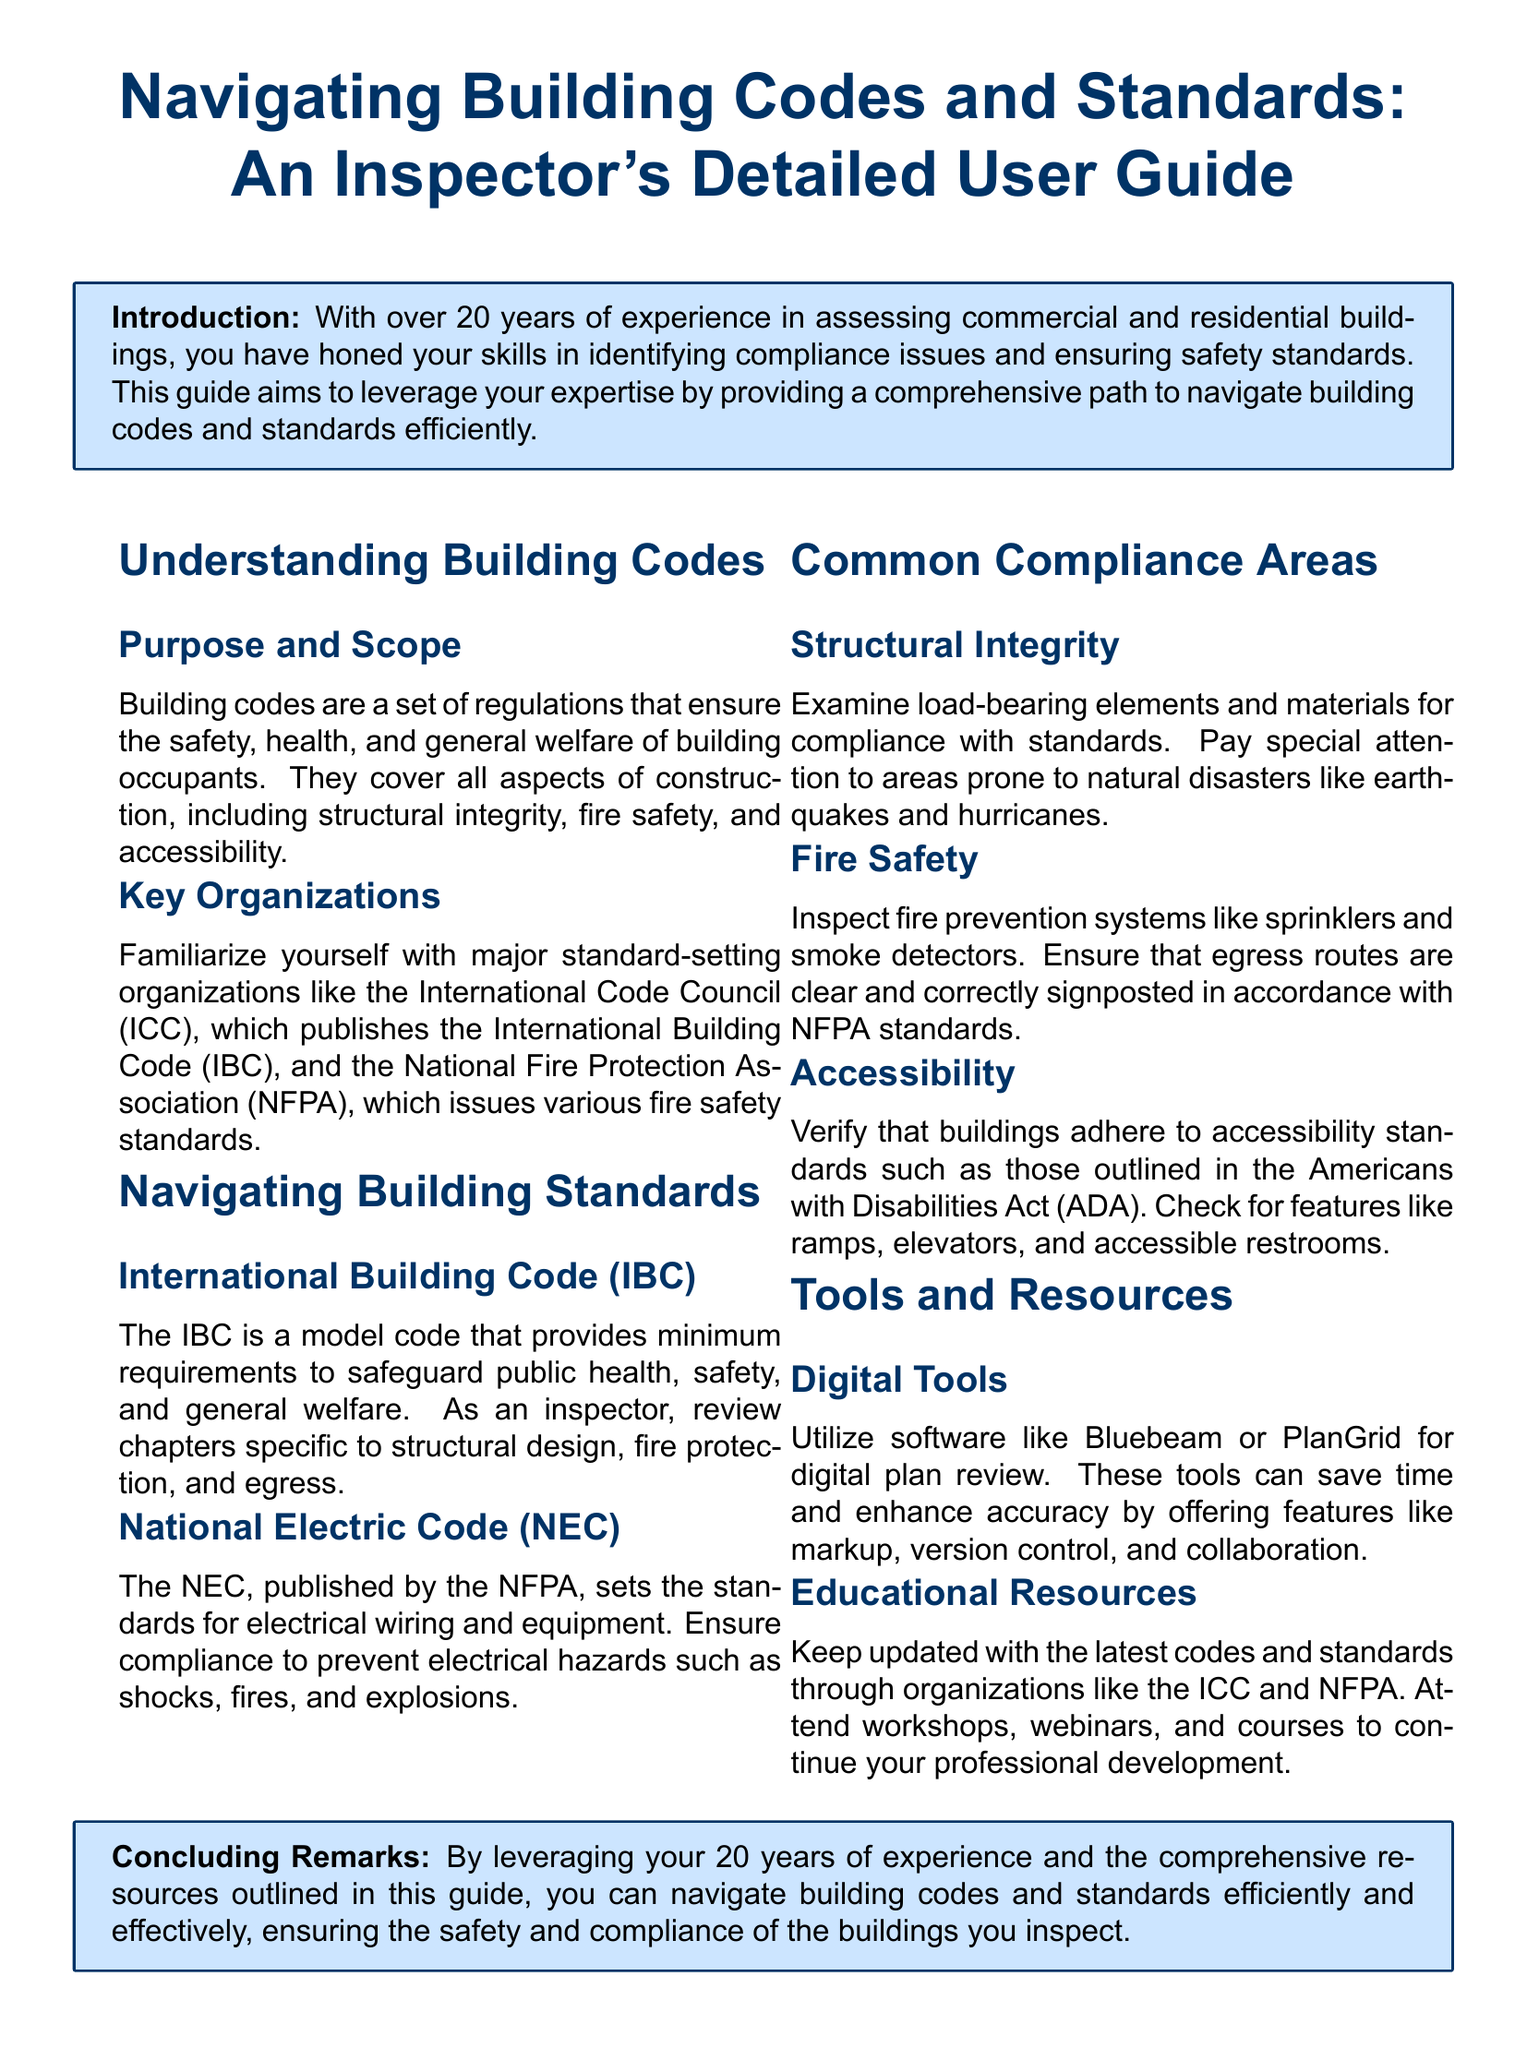What is the purpose of building codes? Building codes ensure the safety, health, and general welfare of building occupants.
Answer: Safety, health, and general welfare What organization publishes the International Building Code? The International Code Council (ICC) is the organization that publishes this model code.
Answer: International Code Council (ICC) Which standard deals with electrical wiring and equipment? The National Electric Code (NEC) establishes standards for electrical systems to enhance safety.
Answer: National Electric Code (NEC) Name a common compliance area focused on natural disaster resilience. Structural integrity is a compliance area concerned with load-bearing elements and materials.
Answer: Structural integrity What digital tool can be used for digital plan review? Software like Bluebeam or PlanGrid can be utilized for reviewing building plans digitally.
Answer: Bluebeam or PlanGrid Which act outlines accessibility standards for buildings? The Americans with Disabilities Act (ADA) provides guidelines to ensure accessibility in buildings.
Answer: Americans with Disabilities Act (ADA) What is the main goal of inspecting fire prevention systems? Ensuring compliance with fire safety standards to prevent hazards is the primary goal of these inspections.
Answer: Compliance with fire safety standards How many years of experience does the guide attribute to building inspectors? The guide attributes over 20 years of experience to building inspectors in assessing buildings.
Answer: Over 20 years 